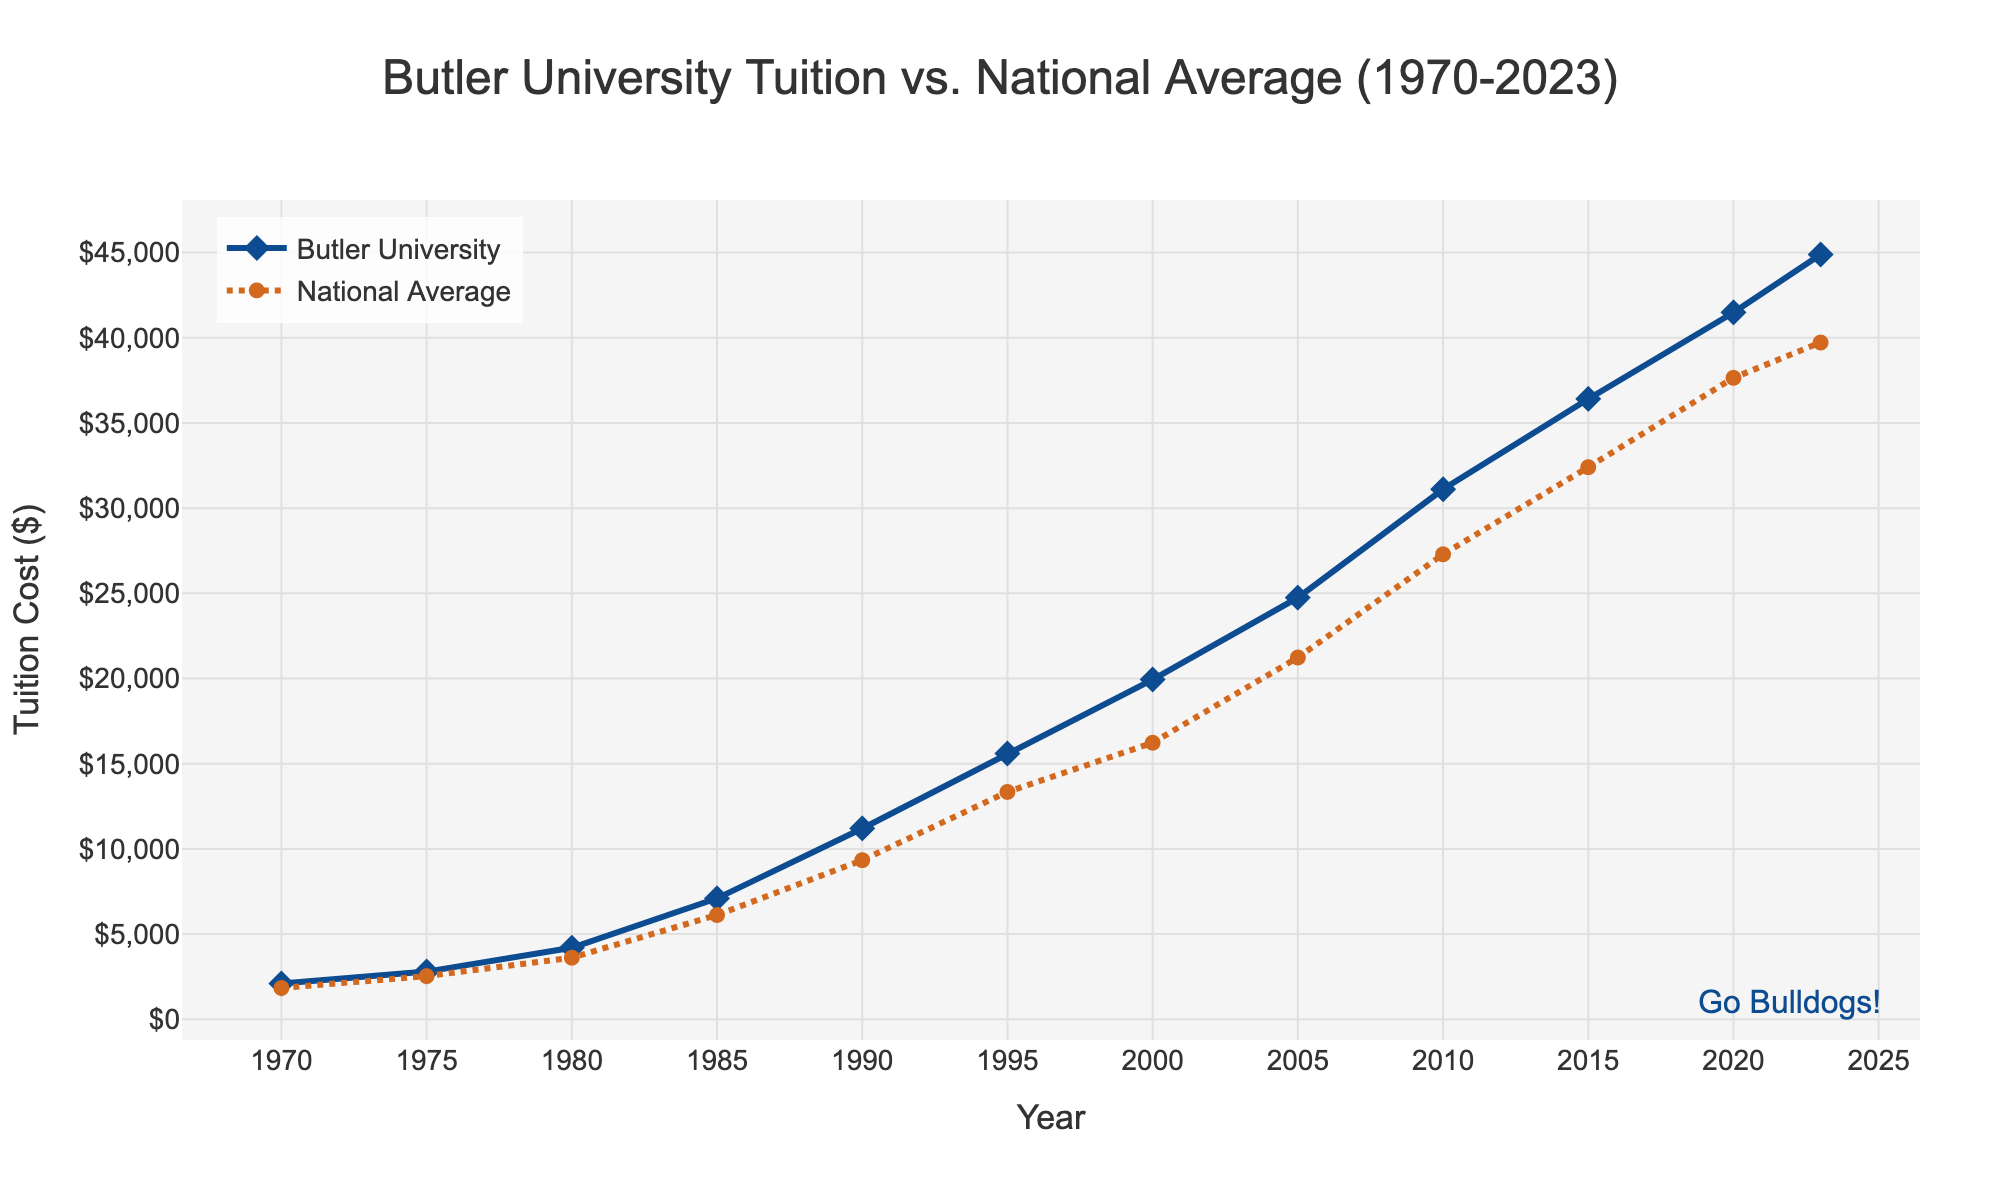What's the tuition cost for Butler University in 1985? The figure will show a point on the Butler University curve corresponding to the year 1985. Identify this point and read the y-axis value, which represents the tuition cost.
Answer: $7100 How does the tuition cost for Butler University in 2023 compare to the national average? Locate the points for Butler University and the National Average for the year 2023. Compare their y-axis values to determine which one is higher and by how much.
Answer: Butler University's tuition is higher by $5167 During which decade did Butler University's tuition see the largest increase? Compare the differences in the tuition costs for each decade (1970s, 1980s, etc.). The largest difference indicates the decade with the most significant tuition increase.
Answer: The 1980s (increase of $5200) Which year shows the closest tuition cost between Butler University and the national average? Calculate the absolute difference in tuition costs between Butler University and the National Average for each year. The smallest difference indicates the closest tuition cost.
Answer: 1980 (difference of $583) On the graph, which trace represents the National Average, and how is it visually different from the Butler University trace? Look for visual elements such as line type, color, and markers that differentiate the National Average trace from the Butler University trace.
Answer: The National Average is represented with a brown, dotted line with circle markers while Butler University uses a blue, solid line with diamond markers Calculate the average tuition cost for Butler University over the entire period (1970-2023). Sum the tuition costs for all provided years for Butler University and divide by the number of years to find the average.
Answer: $20505 By how much did Butler University's tuition increase between 1970 and 1975, and how does this compare to the national average increase over the same period? Calculate the difference in tuition costs between 1970 and 1975 for both Butler University and the National Average. Compare these two differences to see the increase for each.
Answer: Butler University increased by $700, while the national average increased by $697 In which year did Butler University tuition first exceed $10,000? Identify the year where the tuition cost for Butler University crossed $10,000 by observing the y-axis values along the Butler University line.
Answer: 1990 Determine the percentage increase in tuition at Butler University from 1970 to 2023. Use the formula for percentage increase: [(44890 - 2100) / 2100] * 100 and perform the calculation.
Answer: 2037.14% When was the largest single-year jump in Butler University's tuition, and what was the increase? Examine the changes in tuition costs year over year for Butler University and identify the year with the largest single increase.
Answer: 1980, with an increase of $2100 